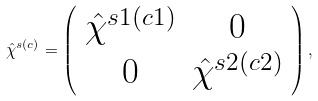<formula> <loc_0><loc_0><loc_500><loc_500>\hat { \chi } ^ { s ( c ) } = \left ( \begin{array} { c c } \hat { \chi } ^ { s 1 ( c 1 ) } & 0 \\ 0 & \hat { \chi } ^ { s 2 ( c 2 ) } \end{array} \right ) ,</formula> 